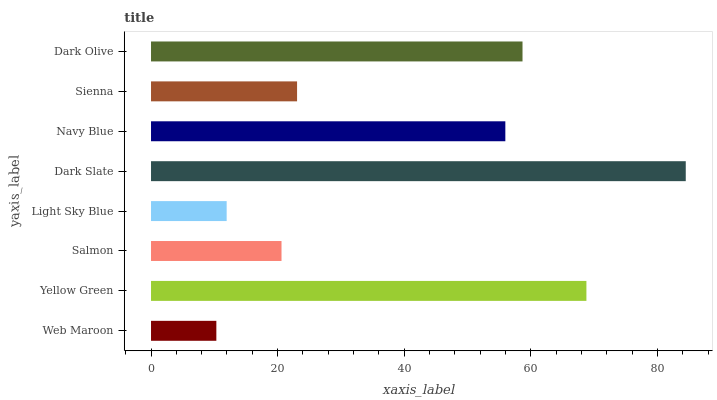Is Web Maroon the minimum?
Answer yes or no. Yes. Is Dark Slate the maximum?
Answer yes or no. Yes. Is Yellow Green the minimum?
Answer yes or no. No. Is Yellow Green the maximum?
Answer yes or no. No. Is Yellow Green greater than Web Maroon?
Answer yes or no. Yes. Is Web Maroon less than Yellow Green?
Answer yes or no. Yes. Is Web Maroon greater than Yellow Green?
Answer yes or no. No. Is Yellow Green less than Web Maroon?
Answer yes or no. No. Is Navy Blue the high median?
Answer yes or no. Yes. Is Sienna the low median?
Answer yes or no. Yes. Is Dark Slate the high median?
Answer yes or no. No. Is Dark Slate the low median?
Answer yes or no. No. 